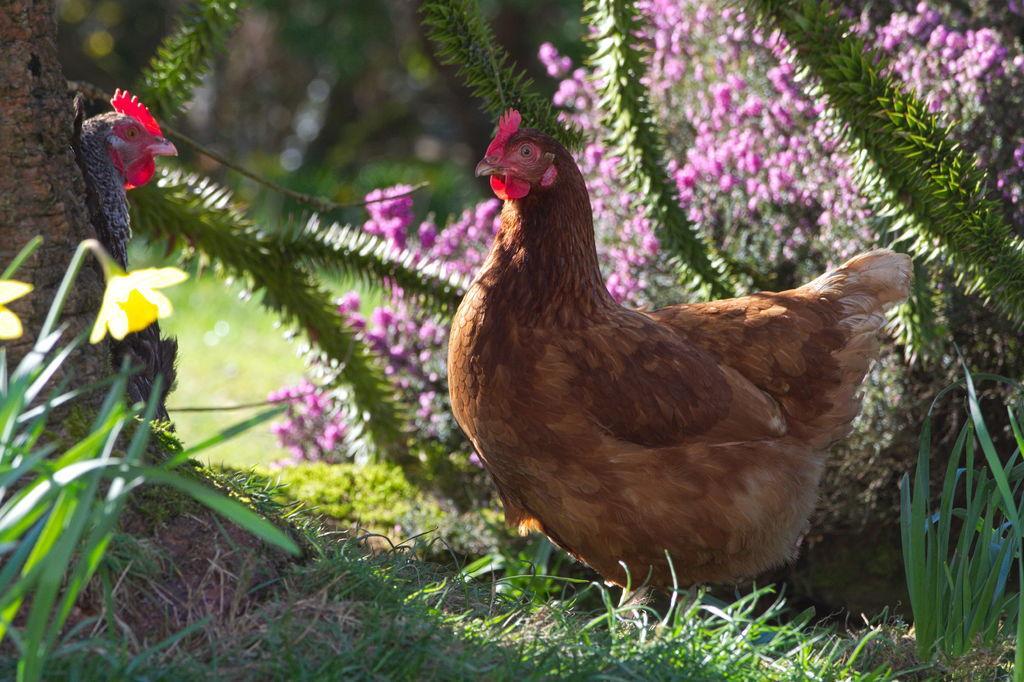In one or two sentences, can you explain what this image depicts? In this picture there are hens and there are purple color and yellow color flowers on the plants. At the bottom there is grass on the ground. 